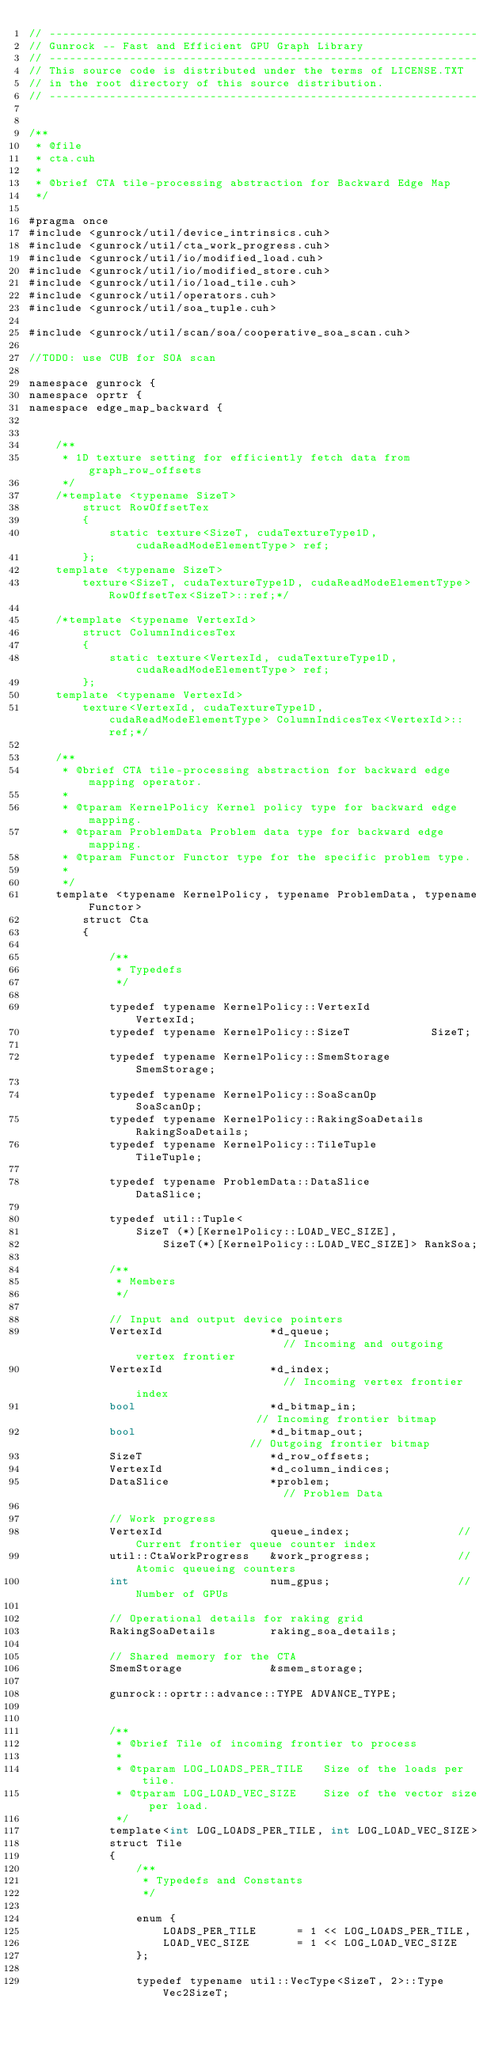<code> <loc_0><loc_0><loc_500><loc_500><_Cuda_>// ----------------------------------------------------------------
// Gunrock -- Fast and Efficient GPU Graph Library
// ----------------------------------------------------------------
// This source code is distributed under the terms of LICENSE.TXT
// in the root directory of this source distribution.
// ----------------------------------------------------------------


/**
 * @file
 * cta.cuh
 *
 * @brief CTA tile-processing abstraction for Backward Edge Map
 */

#pragma once
#include <gunrock/util/device_intrinsics.cuh>
#include <gunrock/util/cta_work_progress.cuh>
#include <gunrock/util/io/modified_load.cuh>
#include <gunrock/util/io/modified_store.cuh>
#include <gunrock/util/io/load_tile.cuh>
#include <gunrock/util/operators.cuh>
#include <gunrock/util/soa_tuple.cuh>

#include <gunrock/util/scan/soa/cooperative_soa_scan.cuh>

//TODO: use CUB for SOA scan

namespace gunrock {
namespace oprtr {
namespace edge_map_backward {


    /**
     * 1D texture setting for efficiently fetch data from graph_row_offsets
     */
    /*template <typename SizeT>
        struct RowOffsetTex
        {
            static texture<SizeT, cudaTextureType1D, cudaReadModeElementType> ref;
        };
    template <typename SizeT>
        texture<SizeT, cudaTextureType1D, cudaReadModeElementType> RowOffsetTex<SizeT>::ref;*/

    /*template <typename VertexId>
        struct ColumnIndicesTex
        {
            static texture<VertexId, cudaTextureType1D, cudaReadModeElementType> ref;
        };
    template <typename VertexId>
        texture<VertexId, cudaTextureType1D, cudaReadModeElementType> ColumnIndicesTex<VertexId>::ref;*/

    /**
     * @brief CTA tile-processing abstraction for backward edge mapping operator.
     *
     * @tparam KernelPolicy Kernel policy type for backward edge mapping.
     * @tparam ProblemData Problem data type for backward edge mapping.
     * @tparam Functor Functor type for the specific problem type.
     *
     */
    template <typename KernelPolicy, typename ProblemData, typename Functor>
        struct Cta
        {

            /**
             * Typedefs
             */

            typedef typename KernelPolicy::VertexId         VertexId;
            typedef typename KernelPolicy::SizeT            SizeT;

            typedef typename KernelPolicy::SmemStorage      SmemStorage;

            typedef typename KernelPolicy::SoaScanOp        SoaScanOp;
            typedef typename KernelPolicy::RakingSoaDetails RakingSoaDetails;
            typedef typename KernelPolicy::TileTuple        TileTuple;
 
            typedef typename ProblemData::DataSlice         DataSlice;

            typedef util::Tuple<
                SizeT (*)[KernelPolicy::LOAD_VEC_SIZE],
                    SizeT(*)[KernelPolicy::LOAD_VEC_SIZE]> RankSoa;

            /**
             * Members
             */

            // Input and output device pointers
            VertexId                *d_queue;                       // Incoming and outgoing vertex frontier
            VertexId                *d_index;                       // Incoming vertex frontier index
            bool                    *d_bitmap_in;                   // Incoming frontier bitmap
            bool                    *d_bitmap_out;                  // Outgoing frontier bitmap
            SizeT                   *d_row_offsets;
            VertexId                *d_column_indices;
            DataSlice               *problem;                       // Problem Data

            // Work progress
            VertexId                queue_index;                // Current frontier queue counter index
            util::CtaWorkProgress   &work_progress;             // Atomic queueing counters
            int                     num_gpus;                   // Number of GPUs

            // Operational details for raking grid
            RakingSoaDetails        raking_soa_details;

            // Shared memory for the CTA
            SmemStorage             &smem_storage;

            gunrock::oprtr::advance::TYPE ADVANCE_TYPE;


            /**
             * @brief Tile of incoming frontier to process
             *
             * @tparam LOG_LOADS_PER_TILE   Size of the loads per tile.
             * @tparam LOG_LOAD_VEC_SIZE    Size of the vector size per load.
             */
            template<int LOG_LOADS_PER_TILE, int LOG_LOAD_VEC_SIZE>
            struct Tile
            {
                /**
                 * Typedefs and Constants
                 */

                enum {
                    LOADS_PER_TILE      = 1 << LOG_LOADS_PER_TILE,
                    LOAD_VEC_SIZE       = 1 << LOG_LOAD_VEC_SIZE
                };

                typedef typename util::VecType<SizeT, 2>::Type Vec2SizeT;
</code> 